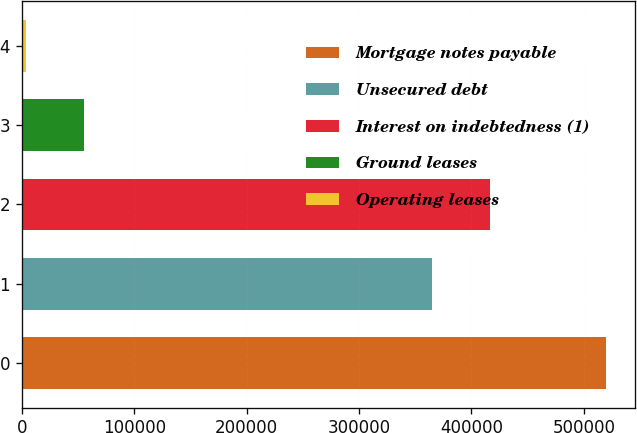Convert chart to OTSL. <chart><loc_0><loc_0><loc_500><loc_500><bar_chart><fcel>Mortgage notes payable<fcel>Unsecured debt<fcel>Interest on indebtedness (1)<fcel>Ground leases<fcel>Operating leases<nl><fcel>519802<fcel>365000<fcel>416624<fcel>55181.5<fcel>3557<nl></chart> 